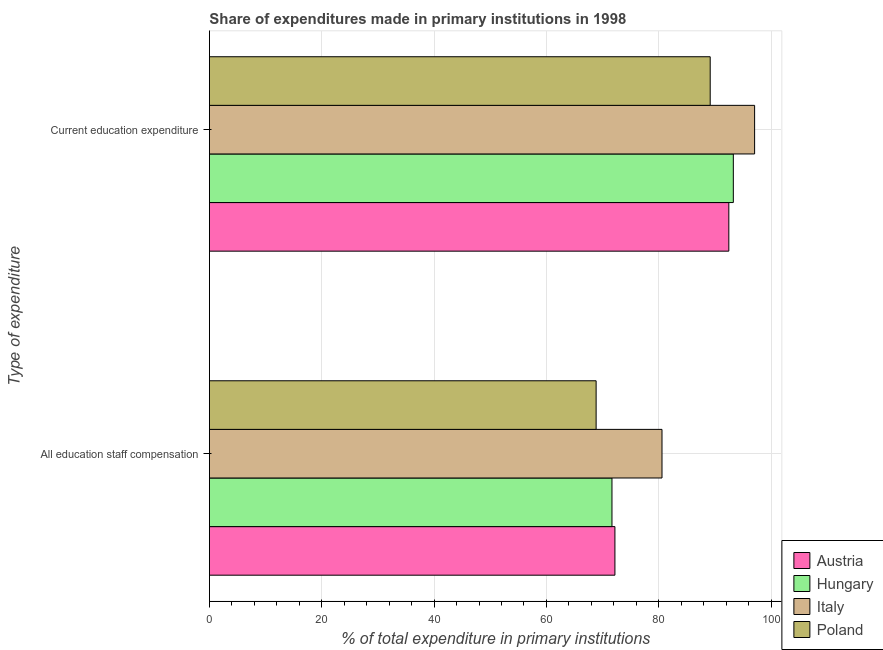How many different coloured bars are there?
Provide a short and direct response. 4. Are the number of bars on each tick of the Y-axis equal?
Keep it short and to the point. Yes. What is the label of the 1st group of bars from the top?
Keep it short and to the point. Current education expenditure. What is the expenditure in staff compensation in Poland?
Give a very brief answer. 68.84. Across all countries, what is the maximum expenditure in staff compensation?
Your answer should be compact. 80.57. Across all countries, what is the minimum expenditure in education?
Your answer should be compact. 89.15. In which country was the expenditure in staff compensation maximum?
Offer a terse response. Italy. What is the total expenditure in staff compensation in the graph?
Provide a short and direct response. 293.26. What is the difference between the expenditure in education in Italy and that in Austria?
Your response must be concise. 4.59. What is the difference between the expenditure in staff compensation in Italy and the expenditure in education in Austria?
Make the answer very short. -11.9. What is the average expenditure in education per country?
Provide a succinct answer. 92.98. What is the difference between the expenditure in education and expenditure in staff compensation in Italy?
Give a very brief answer. 16.49. In how many countries, is the expenditure in education greater than 36 %?
Offer a very short reply. 4. What is the ratio of the expenditure in education in Italy to that in Austria?
Your response must be concise. 1.05. In how many countries, is the expenditure in staff compensation greater than the average expenditure in staff compensation taken over all countries?
Provide a short and direct response. 1. What does the 3rd bar from the top in Current education expenditure represents?
Offer a terse response. Hungary. How many bars are there?
Provide a succinct answer. 8. How many countries are there in the graph?
Offer a terse response. 4. Are the values on the major ticks of X-axis written in scientific E-notation?
Provide a succinct answer. No. Where does the legend appear in the graph?
Provide a succinct answer. Bottom right. How many legend labels are there?
Offer a terse response. 4. How are the legend labels stacked?
Provide a succinct answer. Vertical. What is the title of the graph?
Give a very brief answer. Share of expenditures made in primary institutions in 1998. What is the label or title of the X-axis?
Provide a succinct answer. % of total expenditure in primary institutions. What is the label or title of the Y-axis?
Your response must be concise. Type of expenditure. What is the % of total expenditure in primary institutions in Austria in All education staff compensation?
Provide a succinct answer. 72.19. What is the % of total expenditure in primary institutions in Hungary in All education staff compensation?
Your answer should be very brief. 71.66. What is the % of total expenditure in primary institutions of Italy in All education staff compensation?
Your answer should be very brief. 80.57. What is the % of total expenditure in primary institutions of Poland in All education staff compensation?
Ensure brevity in your answer.  68.84. What is the % of total expenditure in primary institutions of Austria in Current education expenditure?
Provide a succinct answer. 92.46. What is the % of total expenditure in primary institutions of Hungary in Current education expenditure?
Your answer should be very brief. 93.26. What is the % of total expenditure in primary institutions in Italy in Current education expenditure?
Ensure brevity in your answer.  97.05. What is the % of total expenditure in primary institutions of Poland in Current education expenditure?
Offer a very short reply. 89.15. Across all Type of expenditure, what is the maximum % of total expenditure in primary institutions in Austria?
Give a very brief answer. 92.46. Across all Type of expenditure, what is the maximum % of total expenditure in primary institutions of Hungary?
Your answer should be compact. 93.26. Across all Type of expenditure, what is the maximum % of total expenditure in primary institutions in Italy?
Give a very brief answer. 97.05. Across all Type of expenditure, what is the maximum % of total expenditure in primary institutions of Poland?
Provide a short and direct response. 89.15. Across all Type of expenditure, what is the minimum % of total expenditure in primary institutions of Austria?
Your response must be concise. 72.19. Across all Type of expenditure, what is the minimum % of total expenditure in primary institutions in Hungary?
Offer a terse response. 71.66. Across all Type of expenditure, what is the minimum % of total expenditure in primary institutions of Italy?
Ensure brevity in your answer.  80.57. Across all Type of expenditure, what is the minimum % of total expenditure in primary institutions of Poland?
Your answer should be compact. 68.84. What is the total % of total expenditure in primary institutions of Austria in the graph?
Your response must be concise. 164.65. What is the total % of total expenditure in primary institutions of Hungary in the graph?
Your response must be concise. 164.93. What is the total % of total expenditure in primary institutions in Italy in the graph?
Your answer should be compact. 177.62. What is the total % of total expenditure in primary institutions in Poland in the graph?
Provide a succinct answer. 157.99. What is the difference between the % of total expenditure in primary institutions in Austria in All education staff compensation and that in Current education expenditure?
Your response must be concise. -20.28. What is the difference between the % of total expenditure in primary institutions in Hungary in All education staff compensation and that in Current education expenditure?
Offer a very short reply. -21.6. What is the difference between the % of total expenditure in primary institutions of Italy in All education staff compensation and that in Current education expenditure?
Ensure brevity in your answer.  -16.49. What is the difference between the % of total expenditure in primary institutions in Poland in All education staff compensation and that in Current education expenditure?
Provide a succinct answer. -20.31. What is the difference between the % of total expenditure in primary institutions of Austria in All education staff compensation and the % of total expenditure in primary institutions of Hungary in Current education expenditure?
Ensure brevity in your answer.  -21.08. What is the difference between the % of total expenditure in primary institutions of Austria in All education staff compensation and the % of total expenditure in primary institutions of Italy in Current education expenditure?
Offer a terse response. -24.87. What is the difference between the % of total expenditure in primary institutions in Austria in All education staff compensation and the % of total expenditure in primary institutions in Poland in Current education expenditure?
Your answer should be very brief. -16.96. What is the difference between the % of total expenditure in primary institutions in Hungary in All education staff compensation and the % of total expenditure in primary institutions in Italy in Current education expenditure?
Offer a terse response. -25.39. What is the difference between the % of total expenditure in primary institutions of Hungary in All education staff compensation and the % of total expenditure in primary institutions of Poland in Current education expenditure?
Provide a short and direct response. -17.49. What is the difference between the % of total expenditure in primary institutions of Italy in All education staff compensation and the % of total expenditure in primary institutions of Poland in Current education expenditure?
Provide a succinct answer. -8.58. What is the average % of total expenditure in primary institutions in Austria per Type of expenditure?
Provide a succinct answer. 82.33. What is the average % of total expenditure in primary institutions in Hungary per Type of expenditure?
Your response must be concise. 82.46. What is the average % of total expenditure in primary institutions of Italy per Type of expenditure?
Make the answer very short. 88.81. What is the average % of total expenditure in primary institutions of Poland per Type of expenditure?
Your answer should be very brief. 78.99. What is the difference between the % of total expenditure in primary institutions of Austria and % of total expenditure in primary institutions of Hungary in All education staff compensation?
Keep it short and to the point. 0.52. What is the difference between the % of total expenditure in primary institutions of Austria and % of total expenditure in primary institutions of Italy in All education staff compensation?
Provide a succinct answer. -8.38. What is the difference between the % of total expenditure in primary institutions in Austria and % of total expenditure in primary institutions in Poland in All education staff compensation?
Your answer should be very brief. 3.35. What is the difference between the % of total expenditure in primary institutions in Hungary and % of total expenditure in primary institutions in Italy in All education staff compensation?
Your answer should be compact. -8.9. What is the difference between the % of total expenditure in primary institutions in Hungary and % of total expenditure in primary institutions in Poland in All education staff compensation?
Offer a terse response. 2.82. What is the difference between the % of total expenditure in primary institutions in Italy and % of total expenditure in primary institutions in Poland in All education staff compensation?
Give a very brief answer. 11.73. What is the difference between the % of total expenditure in primary institutions of Austria and % of total expenditure in primary institutions of Hungary in Current education expenditure?
Offer a very short reply. -0.8. What is the difference between the % of total expenditure in primary institutions of Austria and % of total expenditure in primary institutions of Italy in Current education expenditure?
Your answer should be compact. -4.59. What is the difference between the % of total expenditure in primary institutions of Austria and % of total expenditure in primary institutions of Poland in Current education expenditure?
Ensure brevity in your answer.  3.32. What is the difference between the % of total expenditure in primary institutions of Hungary and % of total expenditure in primary institutions of Italy in Current education expenditure?
Ensure brevity in your answer.  -3.79. What is the difference between the % of total expenditure in primary institutions of Hungary and % of total expenditure in primary institutions of Poland in Current education expenditure?
Give a very brief answer. 4.12. What is the difference between the % of total expenditure in primary institutions in Italy and % of total expenditure in primary institutions in Poland in Current education expenditure?
Your answer should be compact. 7.91. What is the ratio of the % of total expenditure in primary institutions in Austria in All education staff compensation to that in Current education expenditure?
Your answer should be very brief. 0.78. What is the ratio of the % of total expenditure in primary institutions of Hungary in All education staff compensation to that in Current education expenditure?
Offer a very short reply. 0.77. What is the ratio of the % of total expenditure in primary institutions of Italy in All education staff compensation to that in Current education expenditure?
Keep it short and to the point. 0.83. What is the ratio of the % of total expenditure in primary institutions in Poland in All education staff compensation to that in Current education expenditure?
Your answer should be very brief. 0.77. What is the difference between the highest and the second highest % of total expenditure in primary institutions of Austria?
Provide a short and direct response. 20.28. What is the difference between the highest and the second highest % of total expenditure in primary institutions of Hungary?
Offer a terse response. 21.6. What is the difference between the highest and the second highest % of total expenditure in primary institutions of Italy?
Provide a short and direct response. 16.49. What is the difference between the highest and the second highest % of total expenditure in primary institutions of Poland?
Your answer should be compact. 20.31. What is the difference between the highest and the lowest % of total expenditure in primary institutions of Austria?
Offer a very short reply. 20.28. What is the difference between the highest and the lowest % of total expenditure in primary institutions in Hungary?
Give a very brief answer. 21.6. What is the difference between the highest and the lowest % of total expenditure in primary institutions in Italy?
Provide a short and direct response. 16.49. What is the difference between the highest and the lowest % of total expenditure in primary institutions of Poland?
Ensure brevity in your answer.  20.31. 